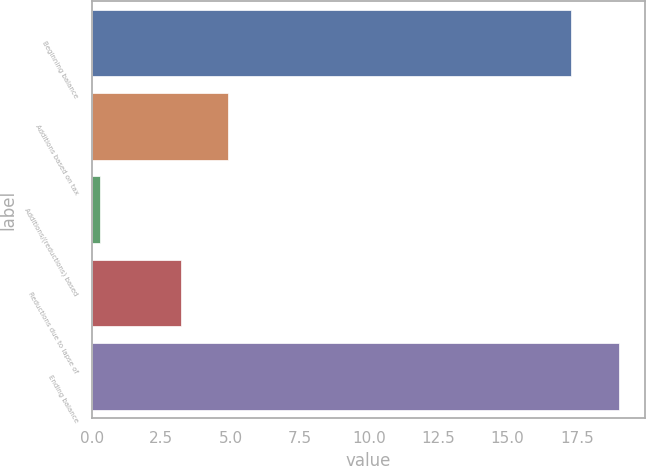Convert chart. <chart><loc_0><loc_0><loc_500><loc_500><bar_chart><fcel>Beginning balance<fcel>Additions based on tax<fcel>Additions/(reductions) based<fcel>Reductions due to lapse of<fcel>Ending balance<nl><fcel>17.3<fcel>4.91<fcel>0.3<fcel>3.2<fcel>19.01<nl></chart> 